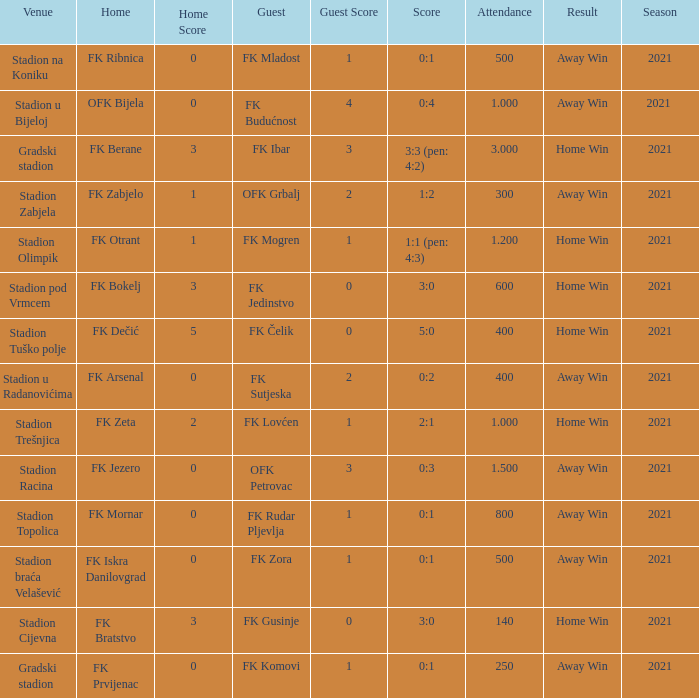What was the attendance of the game that had an away team of FK Mogren? 1.2. 